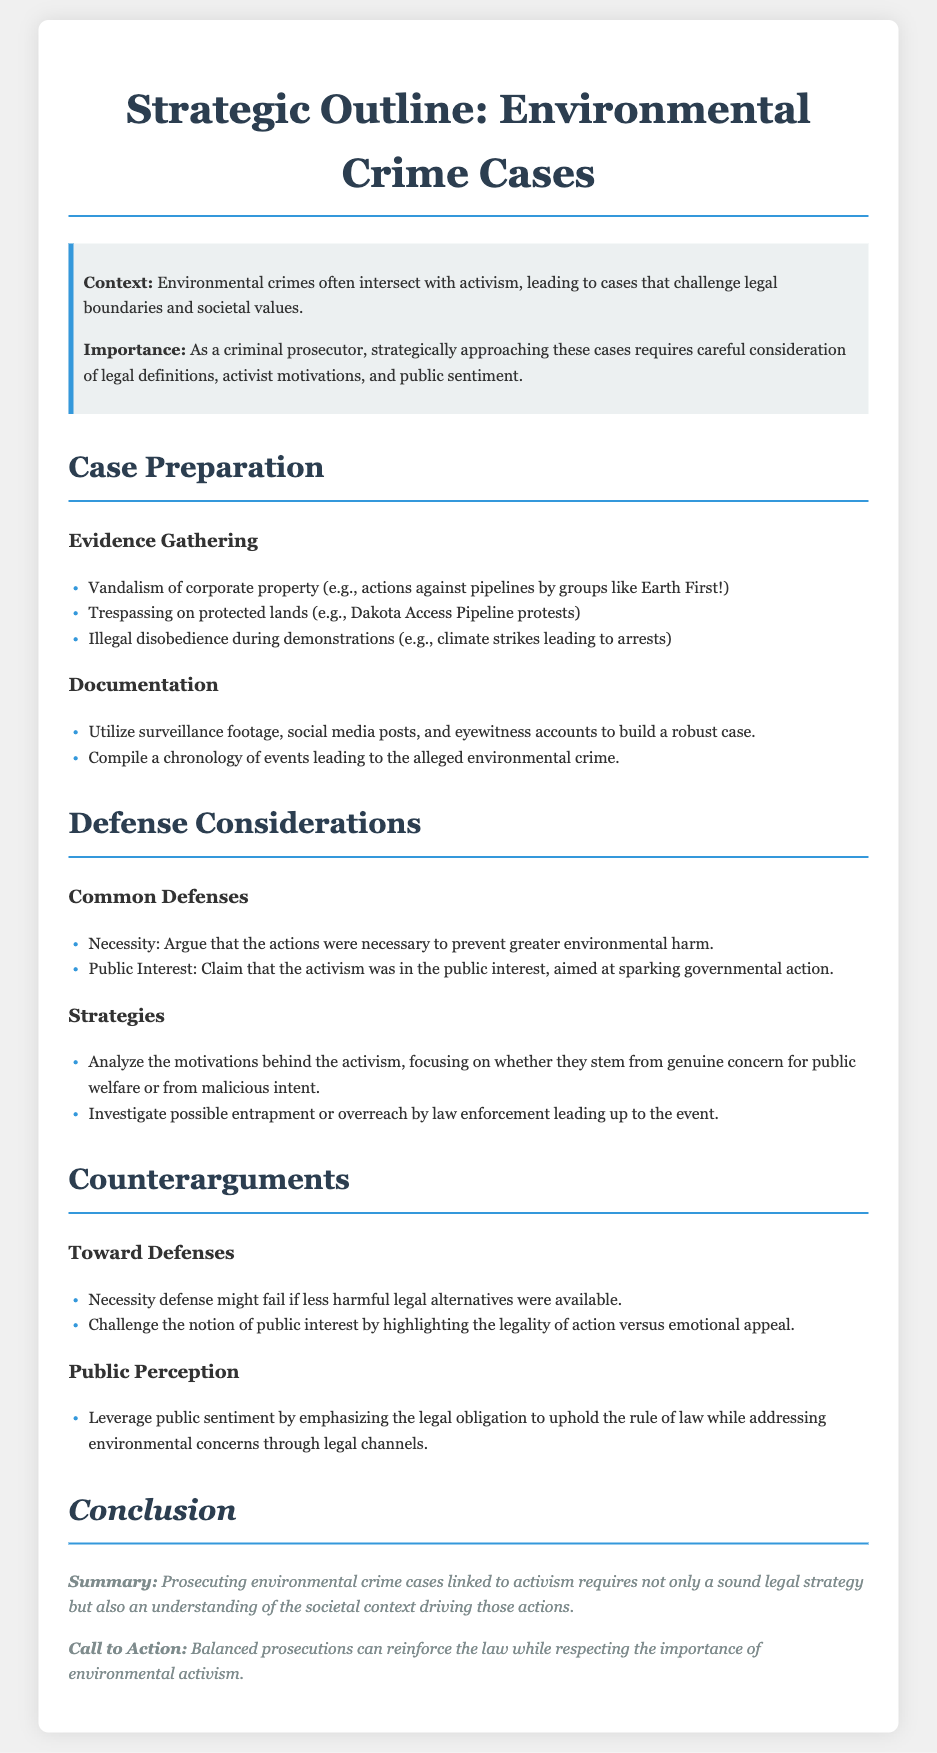What is the main context of environmental crime cases? The context states that environmental crimes often intersect with activism, leading to cases that challenge legal boundaries and societal values.
Answer: Intersection with activism What are examples of evidence gathering? The document lists vandalism of corporate property, trespassing on protected lands, and illegal disobedience during demonstrations as examples.
Answer: Vandalism, trespassing, disobedience What is a common defense mentioned in the document? The document mentions the necessity defense as a common defense strategy.
Answer: Necessity How can public perception be leveraged according to the document? The document suggests leveraging public sentiment by emphasizing the legal obligation to uphold the rule of law while addressing environmental concerns.
Answer: Uphold the rule of law What factors should be analyzed regarding activist motivations? The document states that motivations behind activism should be analyzed to determine whether they stem from genuine concern for public welfare or malicious intent.
Answer: Genuine concern or malicious intent How does the document categorize common defenses? The common defenses are categorized under a specific section titled "Common Defenses" in the document.
Answer: Common Defenses What is the conclusion's summary about prosecuting these cases? The summary in the conclusion states that prosecuting environmental crime cases linked to activism requires a sound legal strategy and understanding of societal context.
Answer: Sound legal strategy and societal context What kind of legal strategy should be examined according to the document? The document implies that strategies should focus on analyzing motivations, potential entrapment, and public interest defenses.
Answer: Analyzing motivations and entrapment What action does the conclusion suggest? The conclusion calls for balanced prosecutions that reinforce the law while respecting environmental activism.
Answer: Balanced prosecutions 